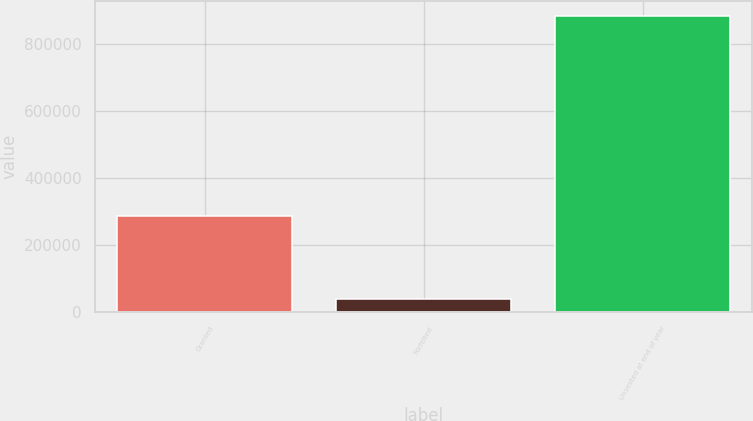Convert chart. <chart><loc_0><loc_0><loc_500><loc_500><bar_chart><fcel>Granted<fcel>Forfeited<fcel>Unvested at end of year<nl><fcel>285800<fcel>38000<fcel>884600<nl></chart> 